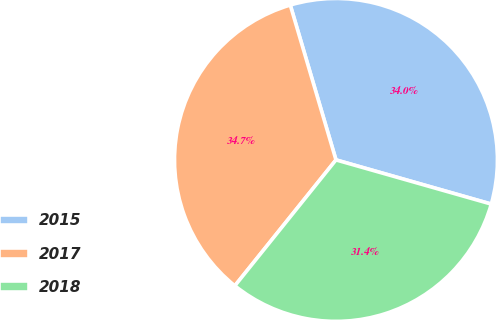Convert chart. <chart><loc_0><loc_0><loc_500><loc_500><pie_chart><fcel>2015<fcel>2017<fcel>2018<nl><fcel>33.98%<fcel>34.66%<fcel>31.36%<nl></chart> 